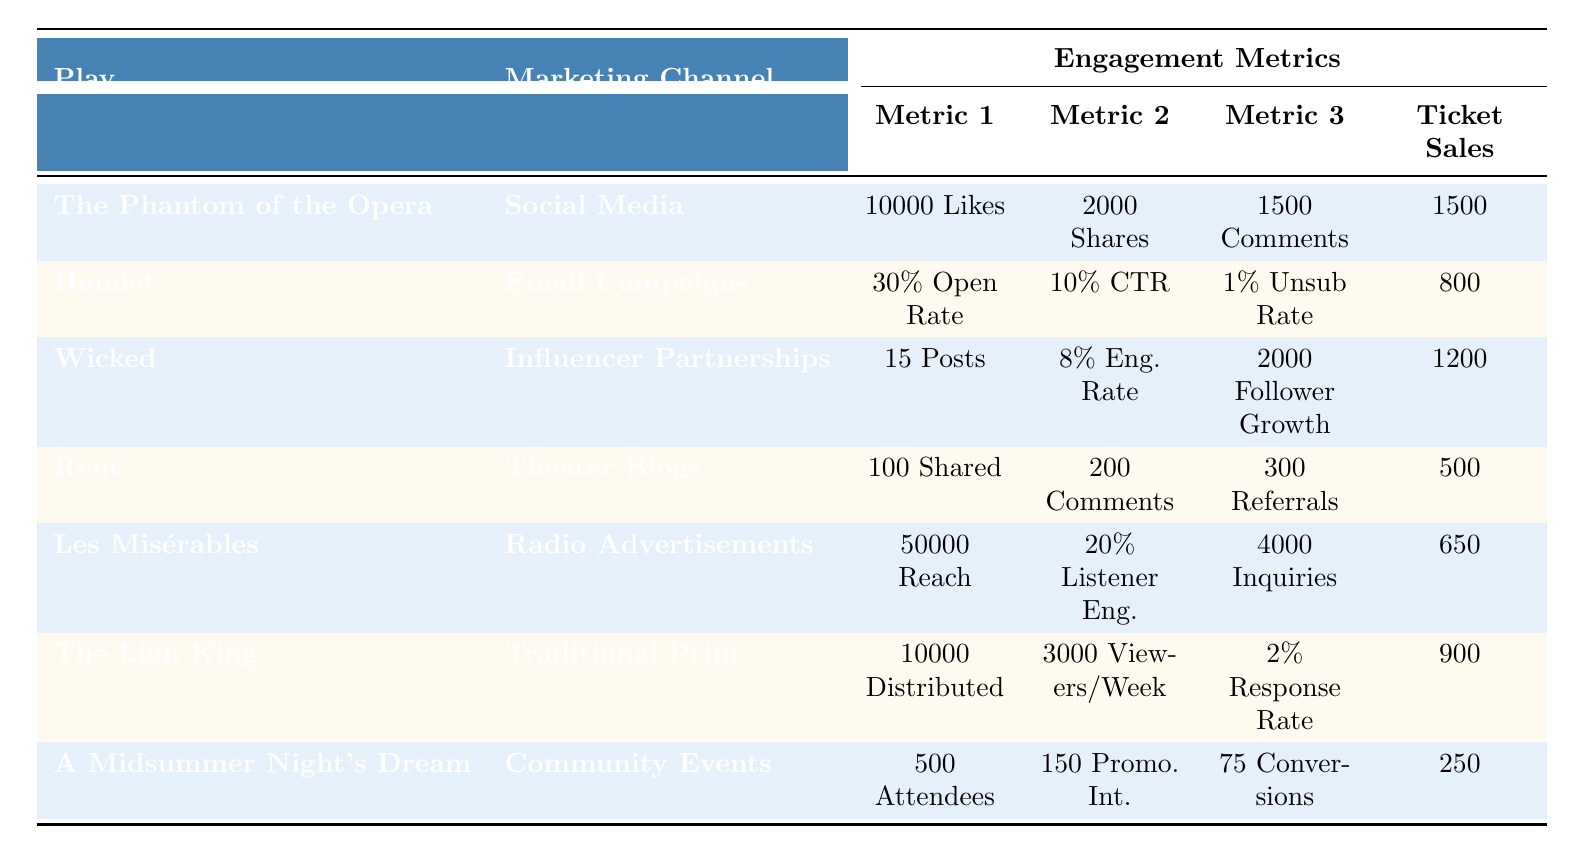What are the ticket sales for "Wicked"? In the table, find the row for "Wicked" under the Play column, and read across to the Ticket Sales column. The value there is 1200.
Answer: 1200 Which marketing channel had the highest engagement rate? Looking at the table, "Wicked" has an engagement rate of 8%, which is the highest among all listed channels.
Answer: 8% What is the total number of likes from "The Phantom of the Opera" and shares from "Les Misérables"? For "The Phantom of the Opera," there are 10000 Likes, and "Les Misérables" has 0 Shares. Add the two values: 10000 + 0 = 10000.
Answer: 10000 Did "A Midsummer Night's Dream" have more ticket sales than "Rent"? The ticket sales for "A Midsummer Night's Dream" are 250, and for "Rent," they are 500. Since 250 is less than 500, the answer is no.
Answer: No What is the average number of inquiries for plays marketed through Radio Advertisements and Community Events? For "Les Misérables," there are 4000 inquiries, and for "A Midsummer Night's Dream," there are 0 inquiries. To find the average, sum them (4000 + 0) = 4000 and then divide by 2, resulting in 4000 / 2 = 2000.
Answer: 2000 Which play had the lowest ticket sales? Scanning through the Ticket Sales column, "A Midsummer Night's Dream" has 250, the lowest of all entries.
Answer: A Midsummer Night's Dream What percentage of ticket sales did "Hamlet" achieve relative to "The Phantom of the Opera"? Ticket sales for "Hamlet" are 800 and for "The Phantom of the Opera," they are 1500. To find the percentage, divide 800 by 1500 (800 / 1500) = 0.5333, then multiply by 100 to convert to a percentage, resulting in approximately 53.33%.
Answer: 53.33% Which marketing channel led to the highest inquiries? Checking the engagement metrics, "Les Misérables" with Radio Advertisements shows 4000 Inquiries, which is the highest compared to the other plays.
Answer: 4000 How many total promotional interactions were achieved across all channels? Adding the numbers: "The Phantom of the Opera" = 0, "Hamlet" = 0, "Wicked" = 0, "Rent" = 0, "Les Misérables" = 0, "The Lion King" = 0, "A Midsummer Night's Dream" = 150. Thus, total promotional interactions = 0 + 0 + 0 + 0 + 0 + 0 + 150 = 150.
Answer: 150 Is there any play that achieved more than 1000 ticket sales through the marketing channel of Social Media? The only play that used Social Media is "The Phantom of the Opera" with 1500 ticket sales, which is more than 1000, so the answer is yes.
Answer: Yes 